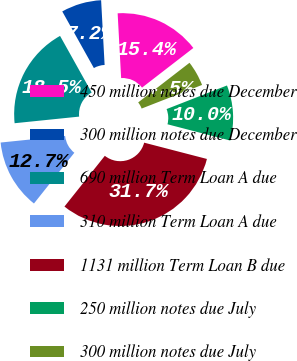Convert chart to OTSL. <chart><loc_0><loc_0><loc_500><loc_500><pie_chart><fcel>450 million notes due December<fcel>300 million notes due December<fcel>690 million Term Loan A due<fcel>310 million Term Loan A due<fcel>1131 million Term Loan B due<fcel>250 million notes due July<fcel>300 million notes due July<nl><fcel>15.39%<fcel>7.25%<fcel>18.52%<fcel>12.68%<fcel>31.66%<fcel>9.97%<fcel>4.54%<nl></chart> 